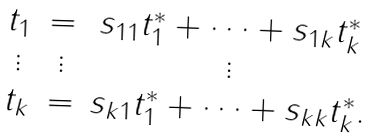Convert formula to latex. <formula><loc_0><loc_0><loc_500><loc_500>\begin{array} { c c c } t _ { 1 } & = & s _ { 1 1 } t ^ { * } _ { 1 } + \dots + s _ { 1 k } t ^ { * } _ { k } \\ \vdots & \vdots & \vdots \\ t _ { k } & = & s _ { k 1 } t ^ { * } _ { 1 } + \dots + s _ { k k } t ^ { * } _ { k } . \end{array}</formula> 